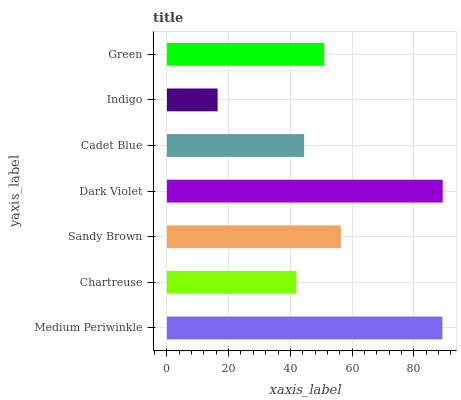Is Indigo the minimum?
Answer yes or no. Yes. Is Dark Violet the maximum?
Answer yes or no. Yes. Is Chartreuse the minimum?
Answer yes or no. No. Is Chartreuse the maximum?
Answer yes or no. No. Is Medium Periwinkle greater than Chartreuse?
Answer yes or no. Yes. Is Chartreuse less than Medium Periwinkle?
Answer yes or no. Yes. Is Chartreuse greater than Medium Periwinkle?
Answer yes or no. No. Is Medium Periwinkle less than Chartreuse?
Answer yes or no. No. Is Green the high median?
Answer yes or no. Yes. Is Green the low median?
Answer yes or no. Yes. Is Medium Periwinkle the high median?
Answer yes or no. No. Is Indigo the low median?
Answer yes or no. No. 